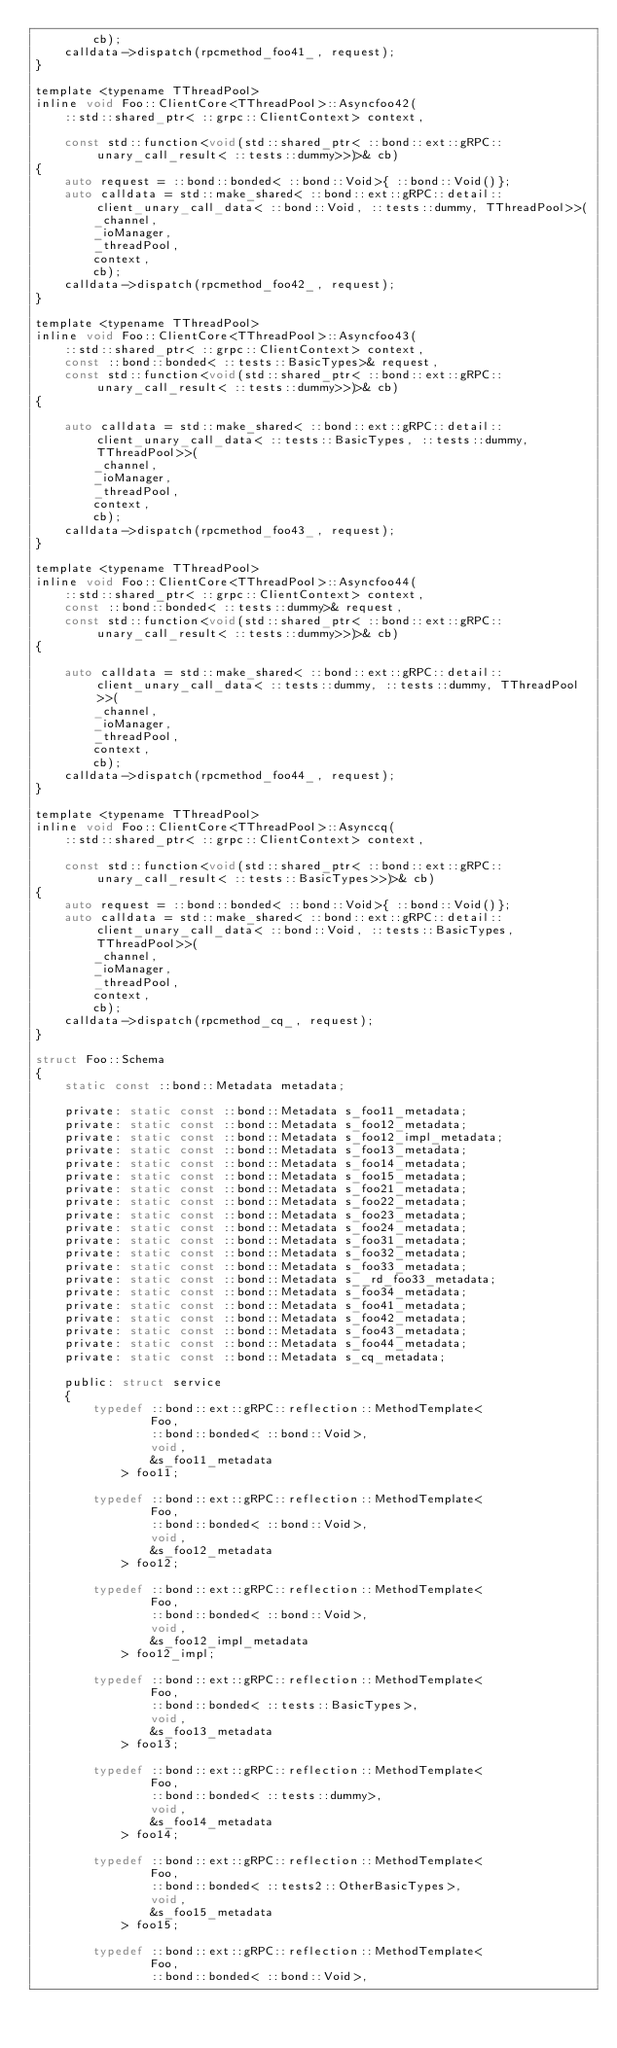Convert code to text. <code><loc_0><loc_0><loc_500><loc_500><_C_>        cb);
    calldata->dispatch(rpcmethod_foo41_, request);
}

template <typename TThreadPool>
inline void Foo::ClientCore<TThreadPool>::Asyncfoo42(
    ::std::shared_ptr< ::grpc::ClientContext> context,
    
    const std::function<void(std::shared_ptr< ::bond::ext::gRPC::unary_call_result< ::tests::dummy>>)>& cb)
{
    auto request = ::bond::bonded< ::bond::Void>{ ::bond::Void()};
    auto calldata = std::make_shared< ::bond::ext::gRPC::detail::client_unary_call_data< ::bond::Void, ::tests::dummy, TThreadPool>>(
        _channel,
        _ioManager,
        _threadPool,
        context,
        cb);
    calldata->dispatch(rpcmethod_foo42_, request);
}

template <typename TThreadPool>
inline void Foo::ClientCore<TThreadPool>::Asyncfoo43(
    ::std::shared_ptr< ::grpc::ClientContext> context,
    const ::bond::bonded< ::tests::BasicTypes>& request,
    const std::function<void(std::shared_ptr< ::bond::ext::gRPC::unary_call_result< ::tests::dummy>>)>& cb)
{
    
    auto calldata = std::make_shared< ::bond::ext::gRPC::detail::client_unary_call_data< ::tests::BasicTypes, ::tests::dummy, TThreadPool>>(
        _channel,
        _ioManager,
        _threadPool,
        context,
        cb);
    calldata->dispatch(rpcmethod_foo43_, request);
}

template <typename TThreadPool>
inline void Foo::ClientCore<TThreadPool>::Asyncfoo44(
    ::std::shared_ptr< ::grpc::ClientContext> context,
    const ::bond::bonded< ::tests::dummy>& request,
    const std::function<void(std::shared_ptr< ::bond::ext::gRPC::unary_call_result< ::tests::dummy>>)>& cb)
{
    
    auto calldata = std::make_shared< ::bond::ext::gRPC::detail::client_unary_call_data< ::tests::dummy, ::tests::dummy, TThreadPool>>(
        _channel,
        _ioManager,
        _threadPool,
        context,
        cb);
    calldata->dispatch(rpcmethod_foo44_, request);
}

template <typename TThreadPool>
inline void Foo::ClientCore<TThreadPool>::Asynccq(
    ::std::shared_ptr< ::grpc::ClientContext> context,
    
    const std::function<void(std::shared_ptr< ::bond::ext::gRPC::unary_call_result< ::tests::BasicTypes>>)>& cb)
{
    auto request = ::bond::bonded< ::bond::Void>{ ::bond::Void()};
    auto calldata = std::make_shared< ::bond::ext::gRPC::detail::client_unary_call_data< ::bond::Void, ::tests::BasicTypes, TThreadPool>>(
        _channel,
        _ioManager,
        _threadPool,
        context,
        cb);
    calldata->dispatch(rpcmethod_cq_, request);
}

struct Foo::Schema
{
    static const ::bond::Metadata metadata;

    private: static const ::bond::Metadata s_foo11_metadata;
    private: static const ::bond::Metadata s_foo12_metadata;
    private: static const ::bond::Metadata s_foo12_impl_metadata;
    private: static const ::bond::Metadata s_foo13_metadata;
    private: static const ::bond::Metadata s_foo14_metadata;
    private: static const ::bond::Metadata s_foo15_metadata;
    private: static const ::bond::Metadata s_foo21_metadata;
    private: static const ::bond::Metadata s_foo22_metadata;
    private: static const ::bond::Metadata s_foo23_metadata;
    private: static const ::bond::Metadata s_foo24_metadata;
    private: static const ::bond::Metadata s_foo31_metadata;
    private: static const ::bond::Metadata s_foo32_metadata;
    private: static const ::bond::Metadata s_foo33_metadata;
    private: static const ::bond::Metadata s__rd_foo33_metadata;
    private: static const ::bond::Metadata s_foo34_metadata;
    private: static const ::bond::Metadata s_foo41_metadata;
    private: static const ::bond::Metadata s_foo42_metadata;
    private: static const ::bond::Metadata s_foo43_metadata;
    private: static const ::bond::Metadata s_foo44_metadata;
    private: static const ::bond::Metadata s_cq_metadata;

    public: struct service
    {
        typedef ::bond::ext::gRPC::reflection::MethodTemplate<
                Foo,
                ::bond::bonded< ::bond::Void>,
                void,
                &s_foo11_metadata
            > foo11;

        typedef ::bond::ext::gRPC::reflection::MethodTemplate<
                Foo,
                ::bond::bonded< ::bond::Void>,
                void,
                &s_foo12_metadata
            > foo12;

        typedef ::bond::ext::gRPC::reflection::MethodTemplate<
                Foo,
                ::bond::bonded< ::bond::Void>,
                void,
                &s_foo12_impl_metadata
            > foo12_impl;

        typedef ::bond::ext::gRPC::reflection::MethodTemplate<
                Foo,
                ::bond::bonded< ::tests::BasicTypes>,
                void,
                &s_foo13_metadata
            > foo13;

        typedef ::bond::ext::gRPC::reflection::MethodTemplate<
                Foo,
                ::bond::bonded< ::tests::dummy>,
                void,
                &s_foo14_metadata
            > foo14;

        typedef ::bond::ext::gRPC::reflection::MethodTemplate<
                Foo,
                ::bond::bonded< ::tests2::OtherBasicTypes>,
                void,
                &s_foo15_metadata
            > foo15;

        typedef ::bond::ext::gRPC::reflection::MethodTemplate<
                Foo,
                ::bond::bonded< ::bond::Void>,</code> 